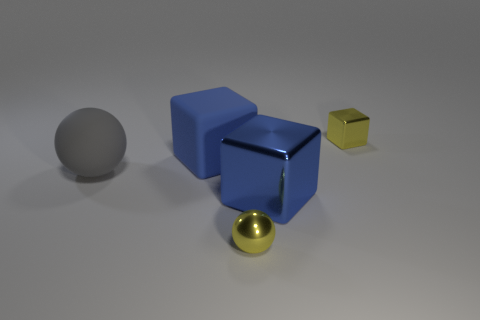There is a rubber ball to the left of the yellow metallic block; does it have the same size as the tiny metallic ball?
Make the answer very short. No. What material is the large blue block that is to the left of the small yellow shiny object in front of the blue thing behind the gray matte sphere?
Make the answer very short. Rubber. Do the large cube in front of the large gray object and the big block that is on the left side of the small yellow ball have the same color?
Your response must be concise. Yes. What is the block that is left of the yellow thing that is in front of the big gray rubber sphere made of?
Your answer should be compact. Rubber. The other cube that is the same size as the blue metal cube is what color?
Offer a terse response. Blue. Is the shape of the blue shiny thing the same as the yellow shiny object in front of the blue matte thing?
Keep it short and to the point. No. What is the shape of the big metal thing that is the same color as the big rubber block?
Provide a succinct answer. Cube. How many large blue rubber blocks are on the right side of the large block right of the yellow object to the left of the small yellow cube?
Make the answer very short. 0. How big is the sphere left of the small yellow thing to the left of the tiny yellow cube?
Keep it short and to the point. Large. What size is the yellow cube that is the same material as the small ball?
Provide a succinct answer. Small. 